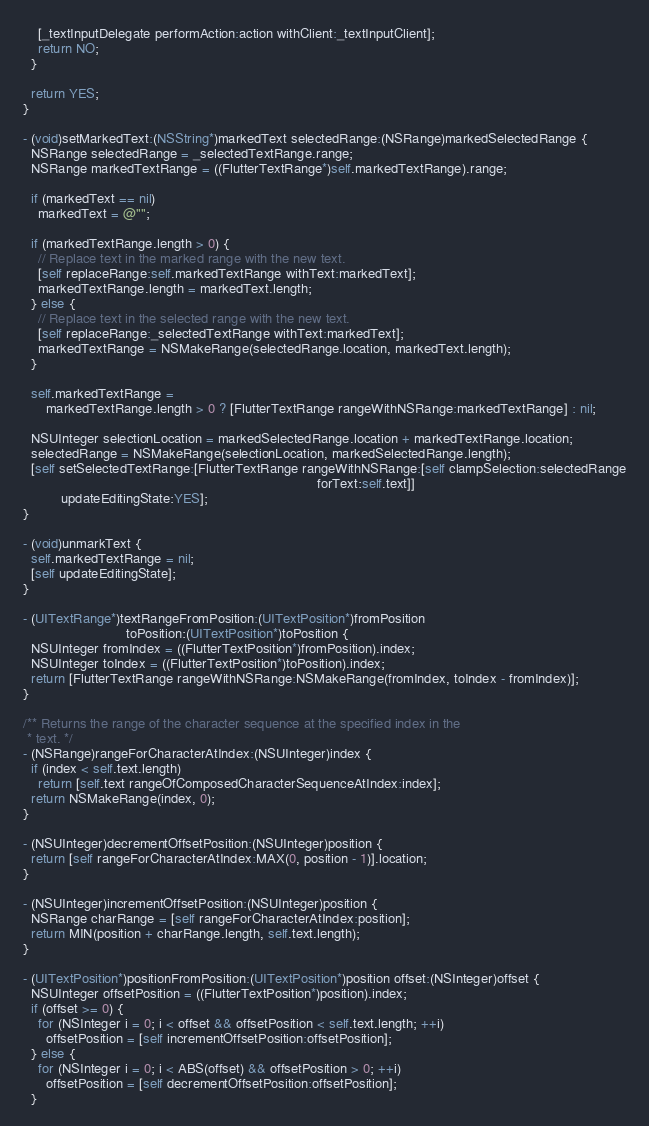Convert code to text. <code><loc_0><loc_0><loc_500><loc_500><_ObjectiveC_>
    [_textInputDelegate performAction:action withClient:_textInputClient];
    return NO;
  }

  return YES;
}

- (void)setMarkedText:(NSString*)markedText selectedRange:(NSRange)markedSelectedRange {
  NSRange selectedRange = _selectedTextRange.range;
  NSRange markedTextRange = ((FlutterTextRange*)self.markedTextRange).range;

  if (markedText == nil)
    markedText = @"";

  if (markedTextRange.length > 0) {
    // Replace text in the marked range with the new text.
    [self replaceRange:self.markedTextRange withText:markedText];
    markedTextRange.length = markedText.length;
  } else {
    // Replace text in the selected range with the new text.
    [self replaceRange:_selectedTextRange withText:markedText];
    markedTextRange = NSMakeRange(selectedRange.location, markedText.length);
  }

  self.markedTextRange =
      markedTextRange.length > 0 ? [FlutterTextRange rangeWithNSRange:markedTextRange] : nil;

  NSUInteger selectionLocation = markedSelectedRange.location + markedTextRange.location;
  selectedRange = NSMakeRange(selectionLocation, markedSelectedRange.length);
  [self setSelectedTextRange:[FlutterTextRange rangeWithNSRange:[self clampSelection:selectedRange
                                                                             forText:self.text]]
          updateEditingState:YES];
}

- (void)unmarkText {
  self.markedTextRange = nil;
  [self updateEditingState];
}

- (UITextRange*)textRangeFromPosition:(UITextPosition*)fromPosition
                           toPosition:(UITextPosition*)toPosition {
  NSUInteger fromIndex = ((FlutterTextPosition*)fromPosition).index;
  NSUInteger toIndex = ((FlutterTextPosition*)toPosition).index;
  return [FlutterTextRange rangeWithNSRange:NSMakeRange(fromIndex, toIndex - fromIndex)];
}

/** Returns the range of the character sequence at the specified index in the
 * text. */
- (NSRange)rangeForCharacterAtIndex:(NSUInteger)index {
  if (index < self.text.length)
    return [self.text rangeOfComposedCharacterSequenceAtIndex:index];
  return NSMakeRange(index, 0);
}

- (NSUInteger)decrementOffsetPosition:(NSUInteger)position {
  return [self rangeForCharacterAtIndex:MAX(0, position - 1)].location;
}

- (NSUInteger)incrementOffsetPosition:(NSUInteger)position {
  NSRange charRange = [self rangeForCharacterAtIndex:position];
  return MIN(position + charRange.length, self.text.length);
}

- (UITextPosition*)positionFromPosition:(UITextPosition*)position offset:(NSInteger)offset {
  NSUInteger offsetPosition = ((FlutterTextPosition*)position).index;
  if (offset >= 0) {
    for (NSInteger i = 0; i < offset && offsetPosition < self.text.length; ++i)
      offsetPosition = [self incrementOffsetPosition:offsetPosition];
  } else {
    for (NSInteger i = 0; i < ABS(offset) && offsetPosition > 0; ++i)
      offsetPosition = [self decrementOffsetPosition:offsetPosition];
  }</code> 